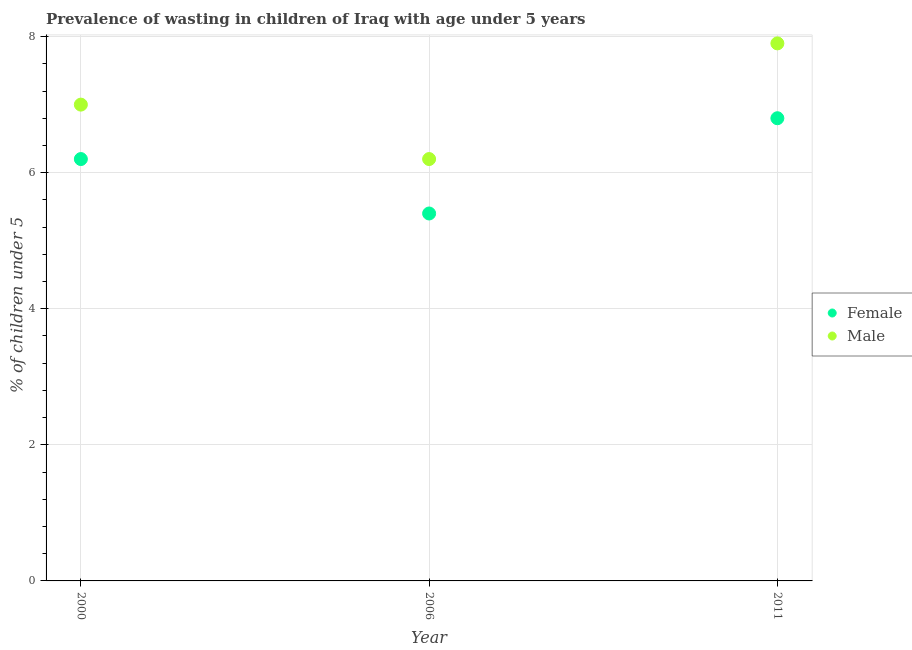What is the percentage of undernourished female children in 2006?
Your answer should be compact. 5.4. Across all years, what is the maximum percentage of undernourished male children?
Make the answer very short. 7.9. Across all years, what is the minimum percentage of undernourished female children?
Give a very brief answer. 5.4. What is the total percentage of undernourished male children in the graph?
Ensure brevity in your answer.  21.1. What is the difference between the percentage of undernourished female children in 2006 and that in 2011?
Offer a terse response. -1.4. What is the difference between the percentage of undernourished male children in 2006 and the percentage of undernourished female children in 2000?
Ensure brevity in your answer.  0. What is the average percentage of undernourished female children per year?
Ensure brevity in your answer.  6.13. In the year 2011, what is the difference between the percentage of undernourished male children and percentage of undernourished female children?
Your answer should be compact. 1.1. What is the ratio of the percentage of undernourished male children in 2000 to that in 2006?
Provide a succinct answer. 1.13. Is the percentage of undernourished male children in 2000 less than that in 2006?
Provide a succinct answer. No. What is the difference between the highest and the second highest percentage of undernourished female children?
Offer a very short reply. 0.6. What is the difference between the highest and the lowest percentage of undernourished male children?
Provide a short and direct response. 1.7. In how many years, is the percentage of undernourished female children greater than the average percentage of undernourished female children taken over all years?
Provide a short and direct response. 2. Does the percentage of undernourished female children monotonically increase over the years?
Keep it short and to the point. No. Is the percentage of undernourished male children strictly greater than the percentage of undernourished female children over the years?
Keep it short and to the point. Yes. Is the percentage of undernourished male children strictly less than the percentage of undernourished female children over the years?
Your answer should be very brief. No. How many dotlines are there?
Your answer should be compact. 2. How many years are there in the graph?
Give a very brief answer. 3. Are the values on the major ticks of Y-axis written in scientific E-notation?
Offer a very short reply. No. Does the graph contain any zero values?
Your answer should be very brief. No. Does the graph contain grids?
Provide a succinct answer. Yes. Where does the legend appear in the graph?
Provide a succinct answer. Center right. How many legend labels are there?
Make the answer very short. 2. How are the legend labels stacked?
Make the answer very short. Vertical. What is the title of the graph?
Provide a short and direct response. Prevalence of wasting in children of Iraq with age under 5 years. What is the label or title of the Y-axis?
Your answer should be very brief.  % of children under 5. What is the  % of children under 5 in Female in 2000?
Your answer should be compact. 6.2. What is the  % of children under 5 in Male in 2000?
Offer a very short reply. 7. What is the  % of children under 5 of Female in 2006?
Keep it short and to the point. 5.4. What is the  % of children under 5 in Male in 2006?
Your response must be concise. 6.2. What is the  % of children under 5 of Female in 2011?
Offer a very short reply. 6.8. What is the  % of children under 5 of Male in 2011?
Provide a succinct answer. 7.9. Across all years, what is the maximum  % of children under 5 of Female?
Provide a short and direct response. 6.8. Across all years, what is the maximum  % of children under 5 of Male?
Offer a very short reply. 7.9. Across all years, what is the minimum  % of children under 5 in Female?
Give a very brief answer. 5.4. Across all years, what is the minimum  % of children under 5 in Male?
Your answer should be very brief. 6.2. What is the total  % of children under 5 of Female in the graph?
Ensure brevity in your answer.  18.4. What is the total  % of children under 5 of Male in the graph?
Provide a short and direct response. 21.1. What is the difference between the  % of children under 5 in Female in 2000 and that in 2006?
Give a very brief answer. 0.8. What is the difference between the  % of children under 5 of Female in 2000 and the  % of children under 5 of Male in 2006?
Keep it short and to the point. 0. What is the difference between the  % of children under 5 in Female in 2000 and the  % of children under 5 in Male in 2011?
Give a very brief answer. -1.7. What is the average  % of children under 5 of Female per year?
Keep it short and to the point. 6.13. What is the average  % of children under 5 of Male per year?
Give a very brief answer. 7.03. In the year 2000, what is the difference between the  % of children under 5 of Female and  % of children under 5 of Male?
Offer a very short reply. -0.8. In the year 2006, what is the difference between the  % of children under 5 of Female and  % of children under 5 of Male?
Ensure brevity in your answer.  -0.8. In the year 2011, what is the difference between the  % of children under 5 in Female and  % of children under 5 in Male?
Ensure brevity in your answer.  -1.1. What is the ratio of the  % of children under 5 in Female in 2000 to that in 2006?
Provide a short and direct response. 1.15. What is the ratio of the  % of children under 5 of Male in 2000 to that in 2006?
Offer a very short reply. 1.13. What is the ratio of the  % of children under 5 of Female in 2000 to that in 2011?
Provide a succinct answer. 0.91. What is the ratio of the  % of children under 5 of Male in 2000 to that in 2011?
Offer a terse response. 0.89. What is the ratio of the  % of children under 5 of Female in 2006 to that in 2011?
Your answer should be compact. 0.79. What is the ratio of the  % of children under 5 in Male in 2006 to that in 2011?
Your response must be concise. 0.78. What is the difference between the highest and the second highest  % of children under 5 in Male?
Make the answer very short. 0.9. 